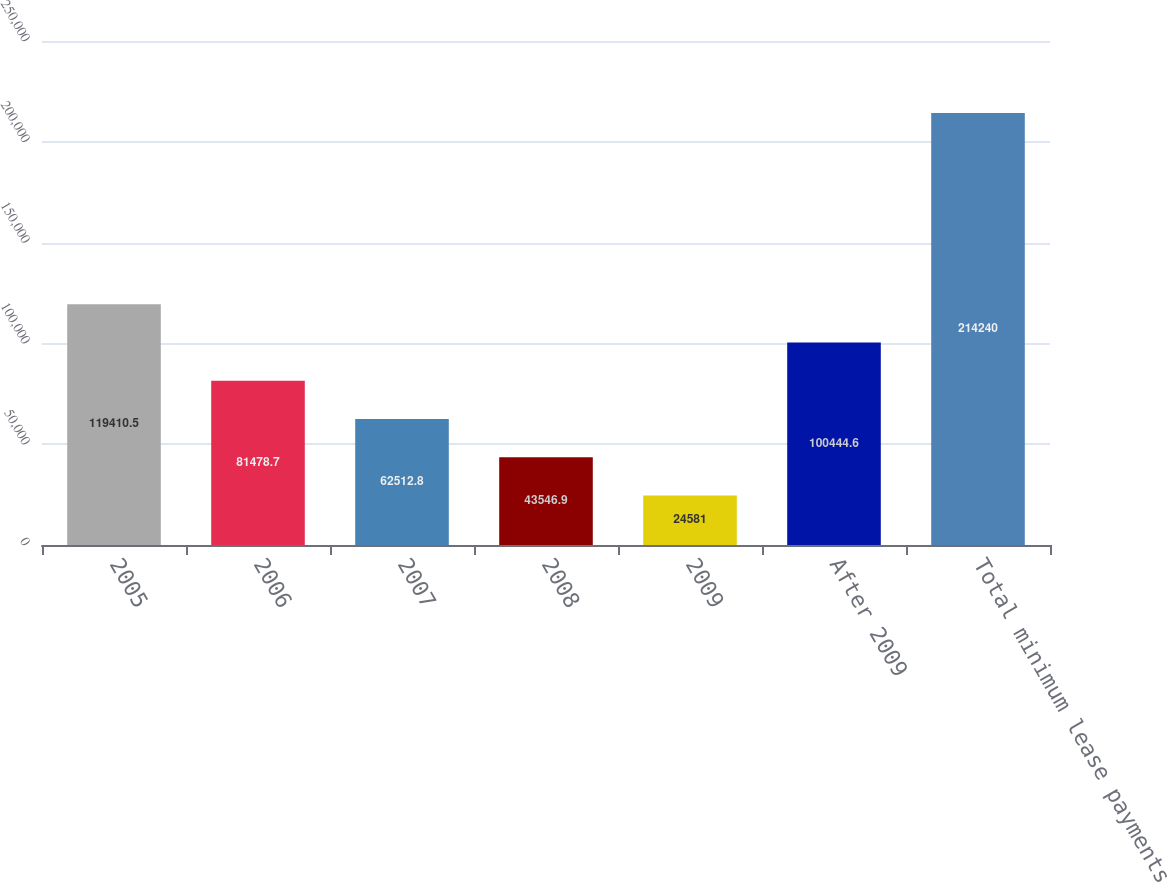Convert chart. <chart><loc_0><loc_0><loc_500><loc_500><bar_chart><fcel>2005<fcel>2006<fcel>2007<fcel>2008<fcel>2009<fcel>After 2009<fcel>Total minimum lease payments<nl><fcel>119410<fcel>81478.7<fcel>62512.8<fcel>43546.9<fcel>24581<fcel>100445<fcel>214240<nl></chart> 